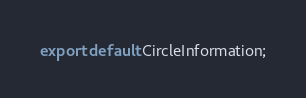Convert code to text. <code><loc_0><loc_0><loc_500><loc_500><_JavaScript_>
export default CircleInformation;
</code> 